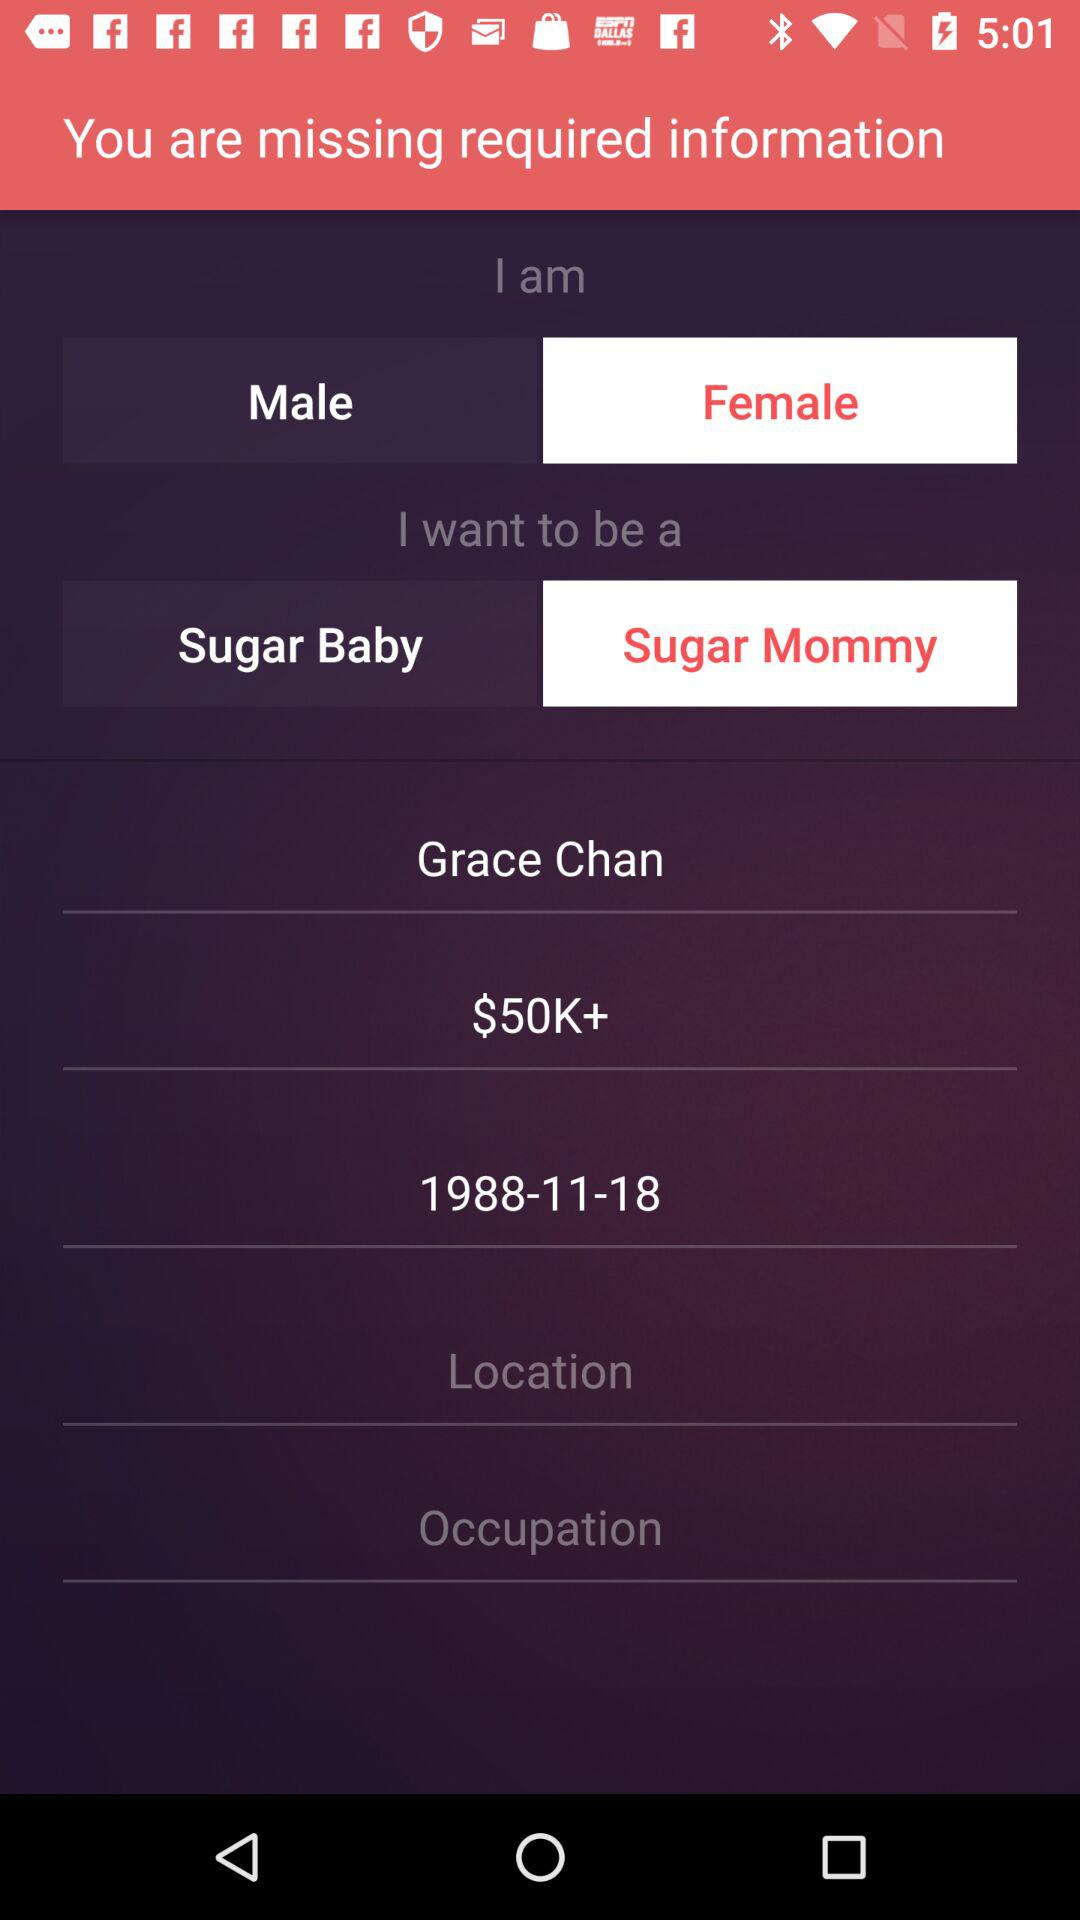What is the date of birth of a user? The date of the birth of a user is 1988-11-18. 